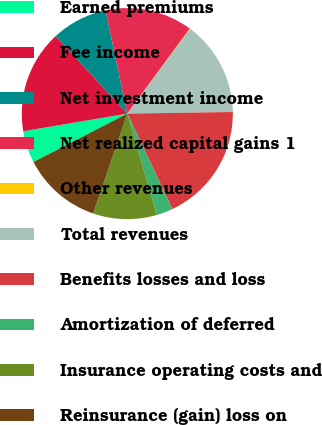<chart> <loc_0><loc_0><loc_500><loc_500><pie_chart><fcel>Earned premiums<fcel>Fee income<fcel>Net investment income<fcel>Net realized capital gains 1<fcel>Other revenues<fcel>Total revenues<fcel>Benefits losses and loss<fcel>Amortization of deferred<fcel>Insurance operating costs and<fcel>Reinsurance (gain) loss on<nl><fcel>4.91%<fcel>15.81%<fcel>8.55%<fcel>13.39%<fcel>0.07%<fcel>14.6%<fcel>18.23%<fcel>2.49%<fcel>9.76%<fcel>12.18%<nl></chart> 